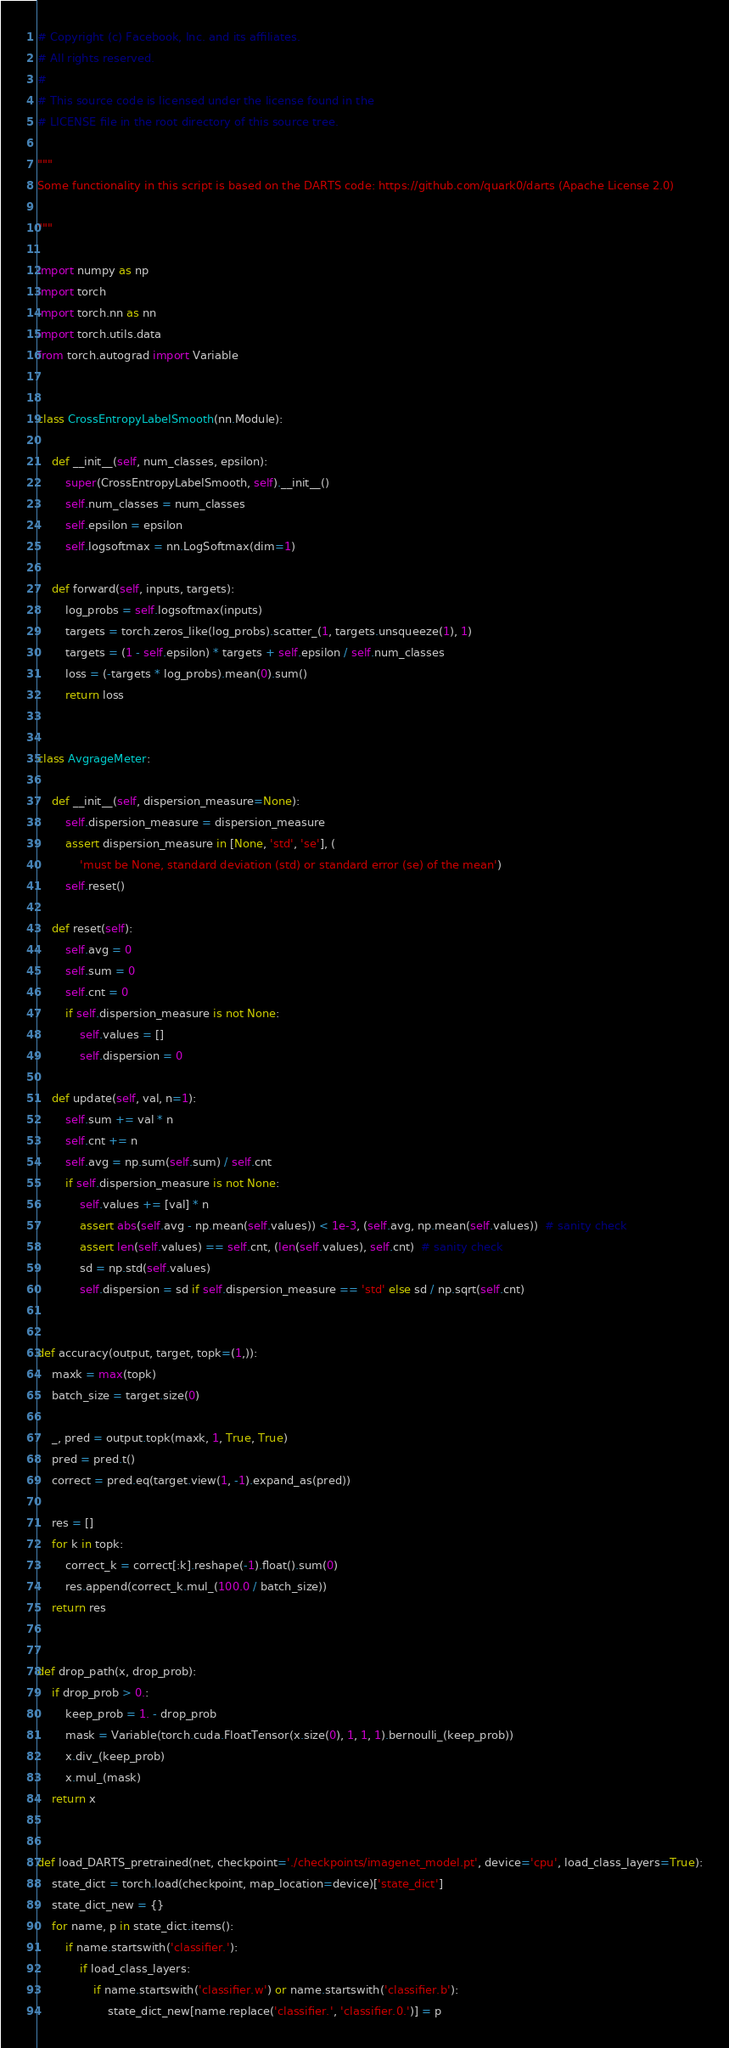<code> <loc_0><loc_0><loc_500><loc_500><_Python_># Copyright (c) Facebook, Inc. and its affiliates.
# All rights reserved.
#
# This source code is licensed under the license found in the
# LICENSE file in the root directory of this source tree.

"""
Some functionality in this script is based on the DARTS code: https://github.com/quark0/darts (Apache License 2.0)

"""

import numpy as np
import torch
import torch.nn as nn
import torch.utils.data
from torch.autograd import Variable


class CrossEntropyLabelSmooth(nn.Module):

    def __init__(self, num_classes, epsilon):
        super(CrossEntropyLabelSmooth, self).__init__()
        self.num_classes = num_classes
        self.epsilon = epsilon
        self.logsoftmax = nn.LogSoftmax(dim=1)

    def forward(self, inputs, targets):
        log_probs = self.logsoftmax(inputs)
        targets = torch.zeros_like(log_probs).scatter_(1, targets.unsqueeze(1), 1)
        targets = (1 - self.epsilon) * targets + self.epsilon / self.num_classes
        loss = (-targets * log_probs).mean(0).sum()
        return loss


class AvgrageMeter:

    def __init__(self, dispersion_measure=None):
        self.dispersion_measure = dispersion_measure
        assert dispersion_measure in [None, 'std', 'se'], (
            'must be None, standard deviation (std) or standard error (se) of the mean')
        self.reset()

    def reset(self):
        self.avg = 0
        self.sum = 0
        self.cnt = 0
        if self.dispersion_measure is not None:
            self.values = []
            self.dispersion = 0

    def update(self, val, n=1):
        self.sum += val * n
        self.cnt += n
        self.avg = np.sum(self.sum) / self.cnt
        if self.dispersion_measure is not None:
            self.values += [val] * n
            assert abs(self.avg - np.mean(self.values)) < 1e-3, (self.avg, np.mean(self.values))  # sanity check
            assert len(self.values) == self.cnt, (len(self.values), self.cnt)  # sanity check
            sd = np.std(self.values)
            self.dispersion = sd if self.dispersion_measure == 'std' else sd / np.sqrt(self.cnt)


def accuracy(output, target, topk=(1,)):
    maxk = max(topk)
    batch_size = target.size(0)

    _, pred = output.topk(maxk, 1, True, True)
    pred = pred.t()
    correct = pred.eq(target.view(1, -1).expand_as(pred))

    res = []
    for k in topk:
        correct_k = correct[:k].reshape(-1).float().sum(0)
        res.append(correct_k.mul_(100.0 / batch_size))
    return res


def drop_path(x, drop_prob):
    if drop_prob > 0.:
        keep_prob = 1. - drop_prob
        mask = Variable(torch.cuda.FloatTensor(x.size(0), 1, 1, 1).bernoulli_(keep_prob))
        x.div_(keep_prob)
        x.mul_(mask)
    return x


def load_DARTS_pretrained(net, checkpoint='./checkpoints/imagenet_model.pt', device='cpu', load_class_layers=True):
    state_dict = torch.load(checkpoint, map_location=device)['state_dict']
    state_dict_new = {}
    for name, p in state_dict.items():
        if name.startswith('classifier.'):
            if load_class_layers:
                if name.startswith('classifier.w') or name.startswith('classifier.b'):
                    state_dict_new[name.replace('classifier.', 'classifier.0.')] = p</code> 